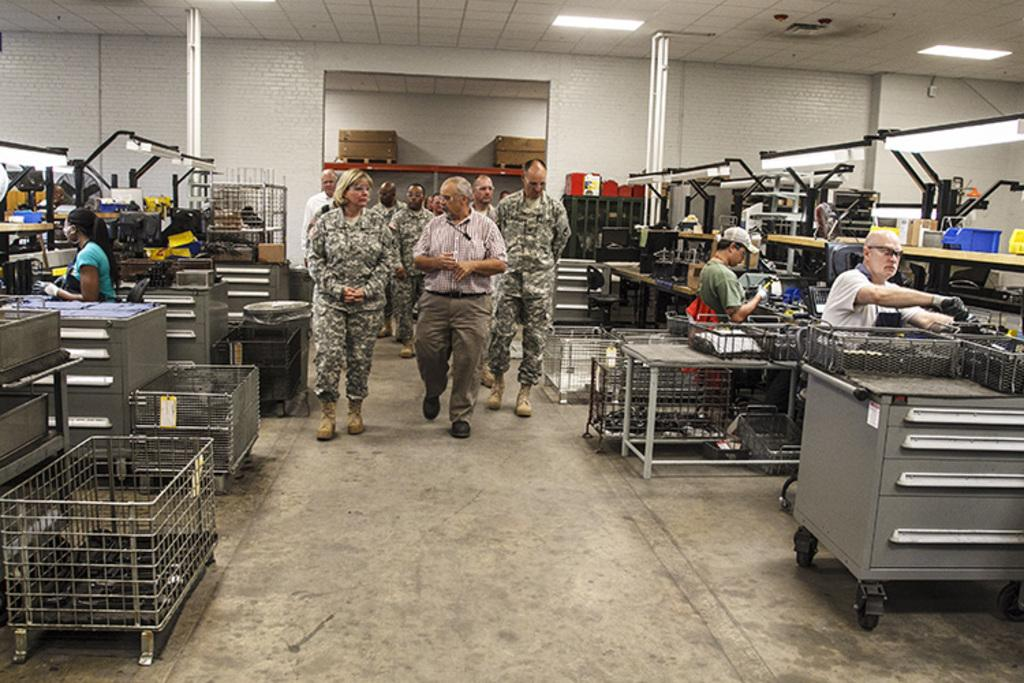What can be seen in the background of the image? There are suitcases in the background of the image. What type of people are present in the image? There are people wearing army dress in the image. What else is visible in the image besides the people? There is a wall and electrical equipment present in the image. How does the vegetable feel about the people in the image? There is no vegetable present in the image, so it cannot have any feelings about the people. 